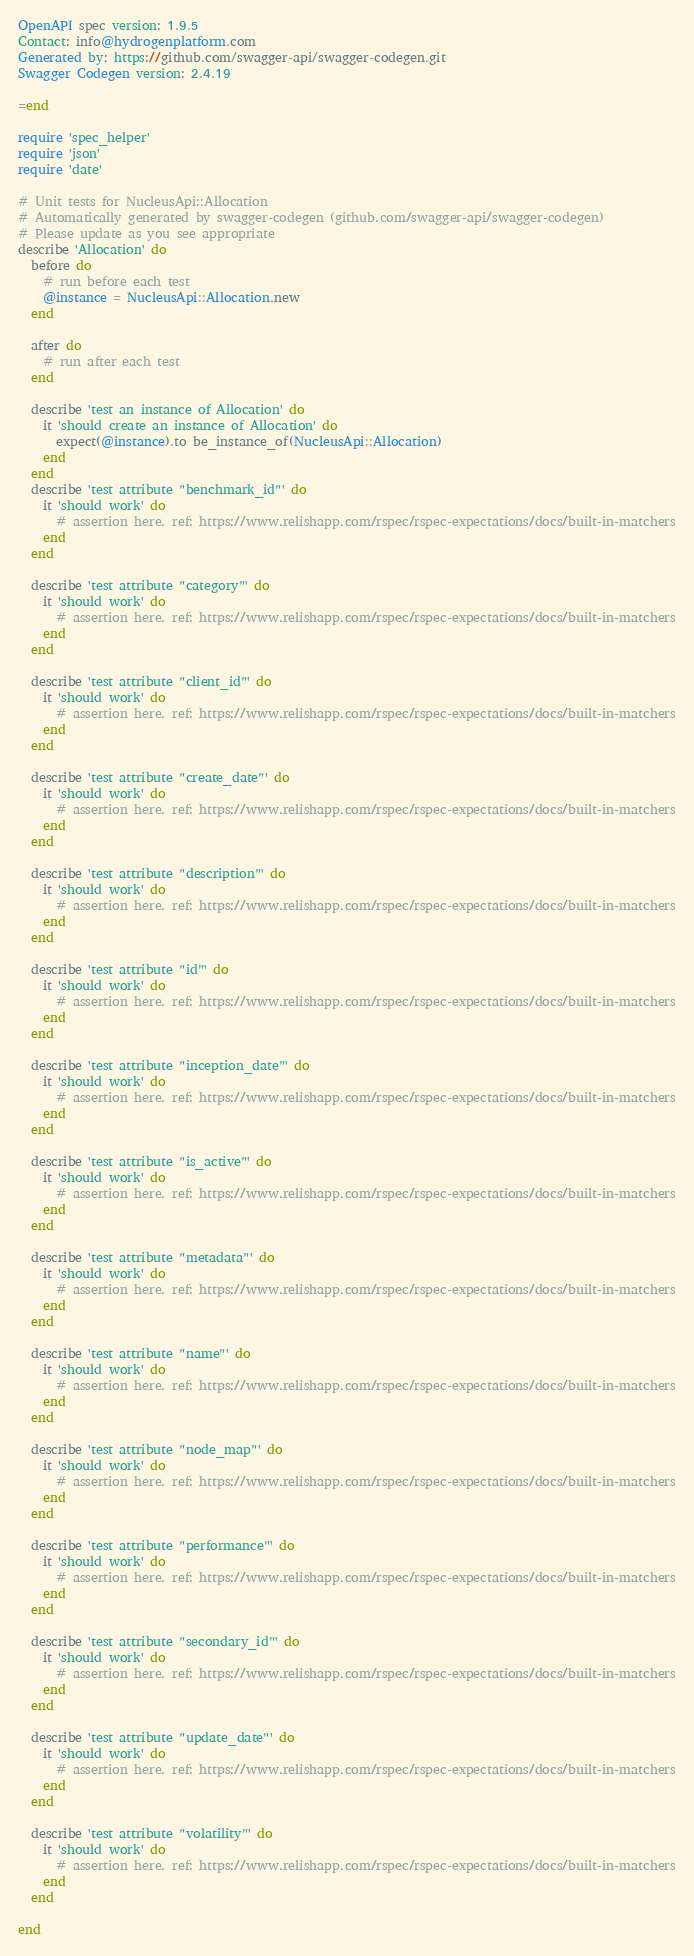Convert code to text. <code><loc_0><loc_0><loc_500><loc_500><_Ruby_>
OpenAPI spec version: 1.9.5
Contact: info@hydrogenplatform.com
Generated by: https://github.com/swagger-api/swagger-codegen.git
Swagger Codegen version: 2.4.19

=end

require 'spec_helper'
require 'json'
require 'date'

# Unit tests for NucleusApi::Allocation
# Automatically generated by swagger-codegen (github.com/swagger-api/swagger-codegen)
# Please update as you see appropriate
describe 'Allocation' do
  before do
    # run before each test
    @instance = NucleusApi::Allocation.new
  end

  after do
    # run after each test
  end

  describe 'test an instance of Allocation' do
    it 'should create an instance of Allocation' do
      expect(@instance).to be_instance_of(NucleusApi::Allocation)
    end
  end
  describe 'test attribute "benchmark_id"' do
    it 'should work' do
      # assertion here. ref: https://www.relishapp.com/rspec/rspec-expectations/docs/built-in-matchers
    end
  end

  describe 'test attribute "category"' do
    it 'should work' do
      # assertion here. ref: https://www.relishapp.com/rspec/rspec-expectations/docs/built-in-matchers
    end
  end

  describe 'test attribute "client_id"' do
    it 'should work' do
      # assertion here. ref: https://www.relishapp.com/rspec/rspec-expectations/docs/built-in-matchers
    end
  end

  describe 'test attribute "create_date"' do
    it 'should work' do
      # assertion here. ref: https://www.relishapp.com/rspec/rspec-expectations/docs/built-in-matchers
    end
  end

  describe 'test attribute "description"' do
    it 'should work' do
      # assertion here. ref: https://www.relishapp.com/rspec/rspec-expectations/docs/built-in-matchers
    end
  end

  describe 'test attribute "id"' do
    it 'should work' do
      # assertion here. ref: https://www.relishapp.com/rspec/rspec-expectations/docs/built-in-matchers
    end
  end

  describe 'test attribute "inception_date"' do
    it 'should work' do
      # assertion here. ref: https://www.relishapp.com/rspec/rspec-expectations/docs/built-in-matchers
    end
  end

  describe 'test attribute "is_active"' do
    it 'should work' do
      # assertion here. ref: https://www.relishapp.com/rspec/rspec-expectations/docs/built-in-matchers
    end
  end

  describe 'test attribute "metadata"' do
    it 'should work' do
      # assertion here. ref: https://www.relishapp.com/rspec/rspec-expectations/docs/built-in-matchers
    end
  end

  describe 'test attribute "name"' do
    it 'should work' do
      # assertion here. ref: https://www.relishapp.com/rspec/rspec-expectations/docs/built-in-matchers
    end
  end

  describe 'test attribute "node_map"' do
    it 'should work' do
      # assertion here. ref: https://www.relishapp.com/rspec/rspec-expectations/docs/built-in-matchers
    end
  end

  describe 'test attribute "performance"' do
    it 'should work' do
      # assertion here. ref: https://www.relishapp.com/rspec/rspec-expectations/docs/built-in-matchers
    end
  end

  describe 'test attribute "secondary_id"' do
    it 'should work' do
      # assertion here. ref: https://www.relishapp.com/rspec/rspec-expectations/docs/built-in-matchers
    end
  end

  describe 'test attribute "update_date"' do
    it 'should work' do
      # assertion here. ref: https://www.relishapp.com/rspec/rspec-expectations/docs/built-in-matchers
    end
  end

  describe 'test attribute "volatility"' do
    it 'should work' do
      # assertion here. ref: https://www.relishapp.com/rspec/rspec-expectations/docs/built-in-matchers
    end
  end

end
</code> 